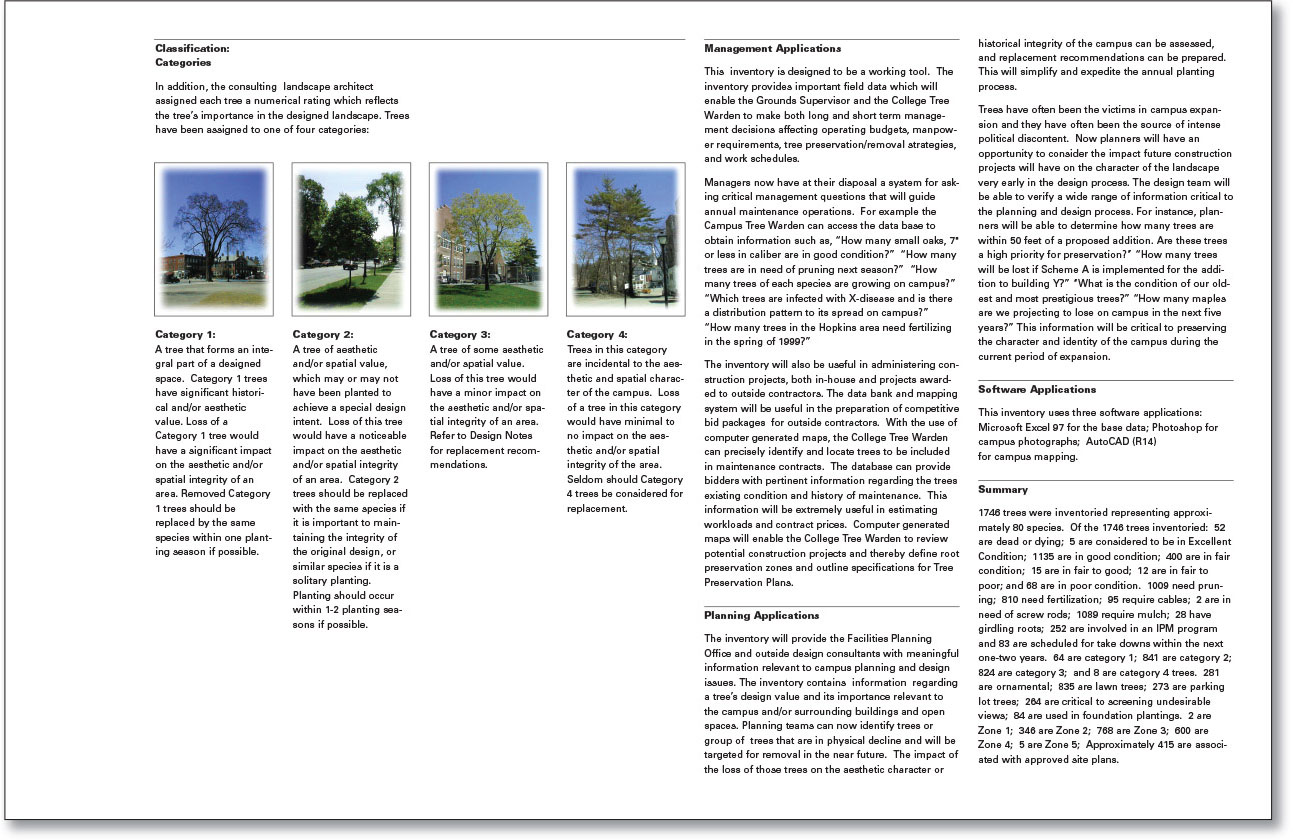What is the significance of the number and condition of trees categorized under Category 4, and how does it relate to the overall campus aesthetics? Category 4 trees are those that are considered incidental to the aesthetic and spatial character of the campus, meaning their loss would have minimal to no impact on the overall appearance or layout. There are 281 trees in Category 4, which represents a relatively small portion compared to the total number of inventoried trees. Because these trees are viewed as less significant to the campus aesthetics, their condition and number are likely deemed lower priority for maintenance and replacement efforts. This categorization helps campus management to allocate resources and attention to trees that have a greater impact on the campus's aesthetic and historical integrity, as detailed in the other categories. 